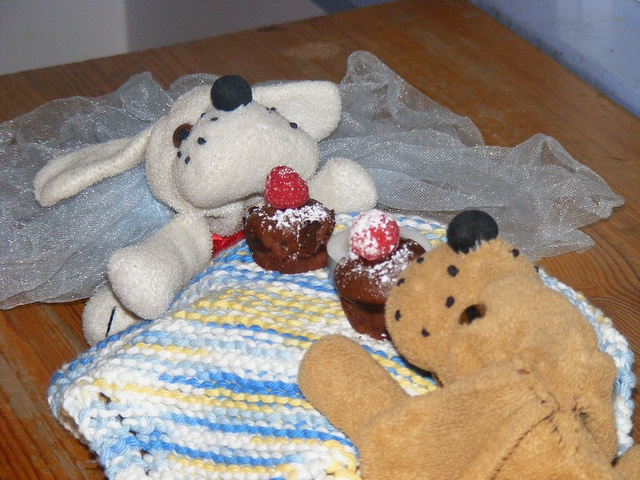Describe the objects in this image and their specific colors. I can see dining table in darkgray, tan, lightgray, gray, and maroon tones, teddy bear in gray, tan, and black tones, teddy bear in gray, darkgray, and lightgray tones, cake in gray, maroon, brown, black, and darkgray tones, and cake in gray, maroon, lightgray, brown, and darkgray tones in this image. 